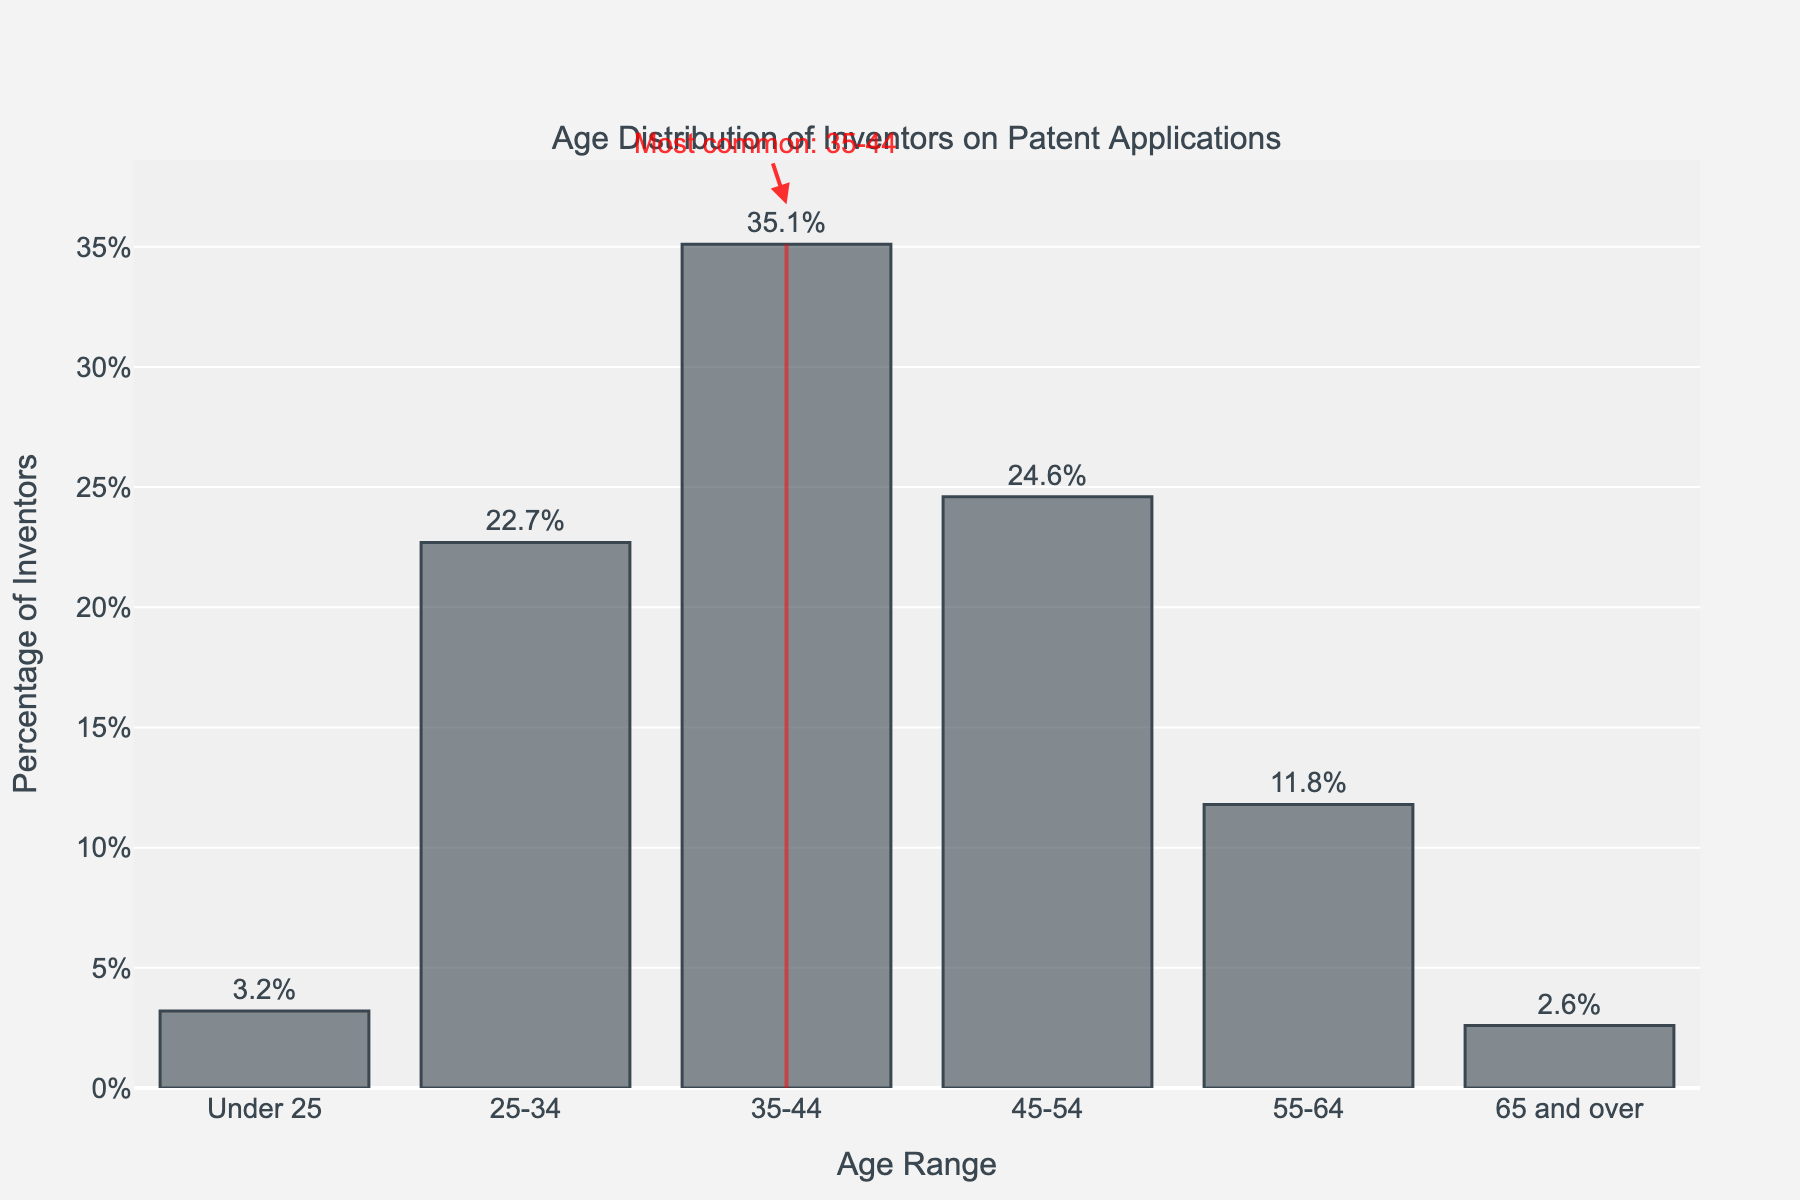What percentage of inventors are aged 35-44? The bar chart shows the percentage of inventors for each age range. For the 35-44 age range, the bar extends to 35.1%.
Answer: 35.1% Which age range has the highest percentage of inventors? By examining the height of the bars, the 35-44 age range has the tallest bar at 35.1%, indicating it has the highest percentage of inventors.
Answer: 35-44 How does the percentage of inventors under 25 compare to those aged 65 and over? The bar for the 'Under 25' age range is at 3.2%, and the bar for '65 and over' is at 2.6%. Therefore, the 'Under 25' age range has a higher percentage.
Answer: Under 25 What's the total percentage of inventors aged 34 and under? Add the percentages of inventors in the 'Under 25' and '25-34' categories: 3.2% + 22.7% = 25.9%.
Answer: 25.9% Which two age ranges combined have the lowest percentage of inventors? Adding the percentages of the various combinations, the 'Under 25' (3.2%) and '65 and over' (2.6%) age ranges together have the lowest combined percentage: 3.2% + 2.6% = 5.8%.
Answer: Under 25 and 65 and over What's the difference in percentage of inventors between the age ranges 45-54 and 55-64? Subtract the percentage of the '55-64' age range from the '45-54' age range: 24.6% - 11.8% = 12.8%.
Answer: 12.8% What age range is highlighted in the figure? The figure includes a visual rectangle shape and an annotation pointing out the most common age range, which is 35-44.
Answer: 35-44 What proportion of inventors are aged 45 and above? Add the percentages of the '45-54', '55-64', and '65 and over' age ranges: 24.6% + 11.8% + 2.6% = 39%.
Answer: 39% 